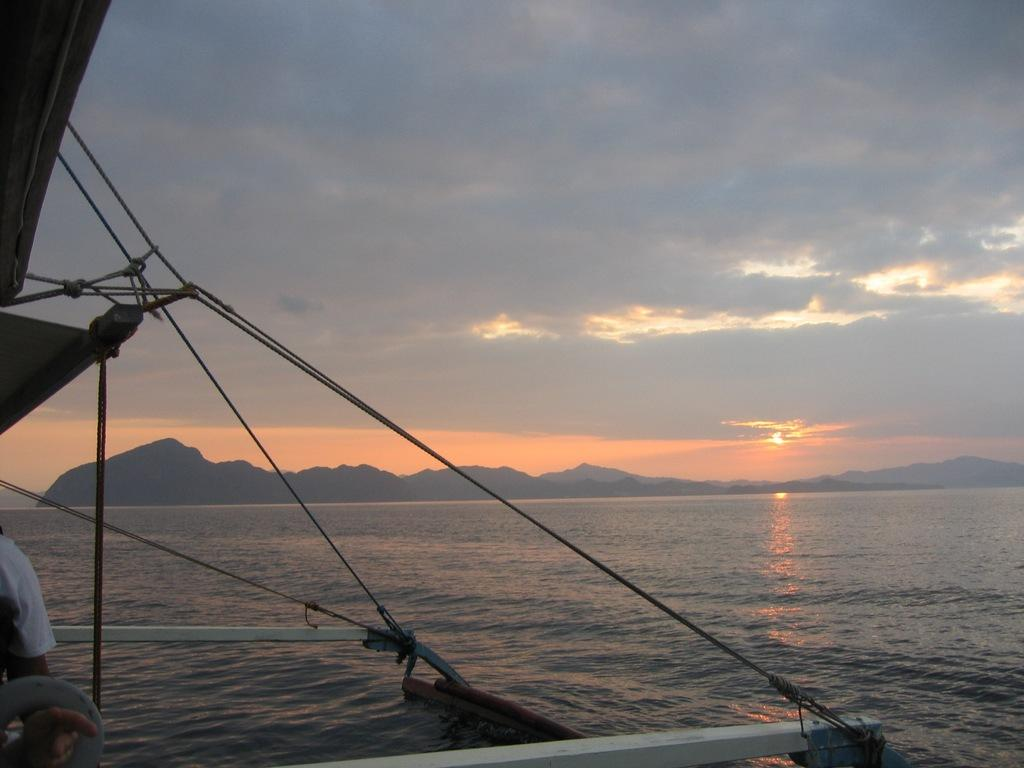What is the main subject of the image? The main subject of the image is a boat. What can be seen around the boat in the image? There is water visible in the image. What is visible in the background of the image? There are hills and the sky visible in the background of the image. What does the boat taste like in the image? The boat is not an edible object, so it does not have a taste. 